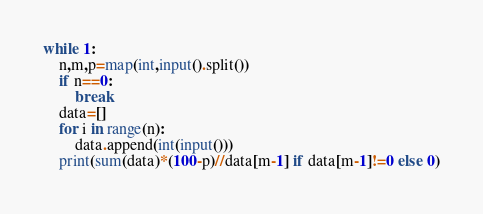Convert code to text. <code><loc_0><loc_0><loc_500><loc_500><_Python_>while 1:
    n,m,p=map(int,input().split())
    if n==0:
        break
    data=[]
    for i in range(n):
        data.append(int(input()))
    print(sum(data)*(100-p)//data[m-1] if data[m-1]!=0 else 0)
</code> 